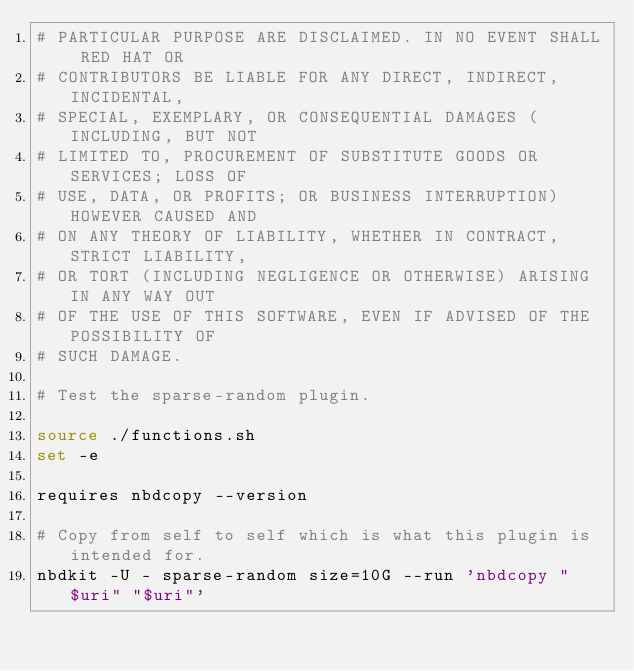<code> <loc_0><loc_0><loc_500><loc_500><_Bash_># PARTICULAR PURPOSE ARE DISCLAIMED. IN NO EVENT SHALL RED HAT OR
# CONTRIBUTORS BE LIABLE FOR ANY DIRECT, INDIRECT, INCIDENTAL,
# SPECIAL, EXEMPLARY, OR CONSEQUENTIAL DAMAGES (INCLUDING, BUT NOT
# LIMITED TO, PROCUREMENT OF SUBSTITUTE GOODS OR SERVICES; LOSS OF
# USE, DATA, OR PROFITS; OR BUSINESS INTERRUPTION) HOWEVER CAUSED AND
# ON ANY THEORY OF LIABILITY, WHETHER IN CONTRACT, STRICT LIABILITY,
# OR TORT (INCLUDING NEGLIGENCE OR OTHERWISE) ARISING IN ANY WAY OUT
# OF THE USE OF THIS SOFTWARE, EVEN IF ADVISED OF THE POSSIBILITY OF
# SUCH DAMAGE.

# Test the sparse-random plugin.

source ./functions.sh
set -e

requires nbdcopy --version

# Copy from self to self which is what this plugin is intended for.
nbdkit -U - sparse-random size=10G --run 'nbdcopy "$uri" "$uri"'
</code> 